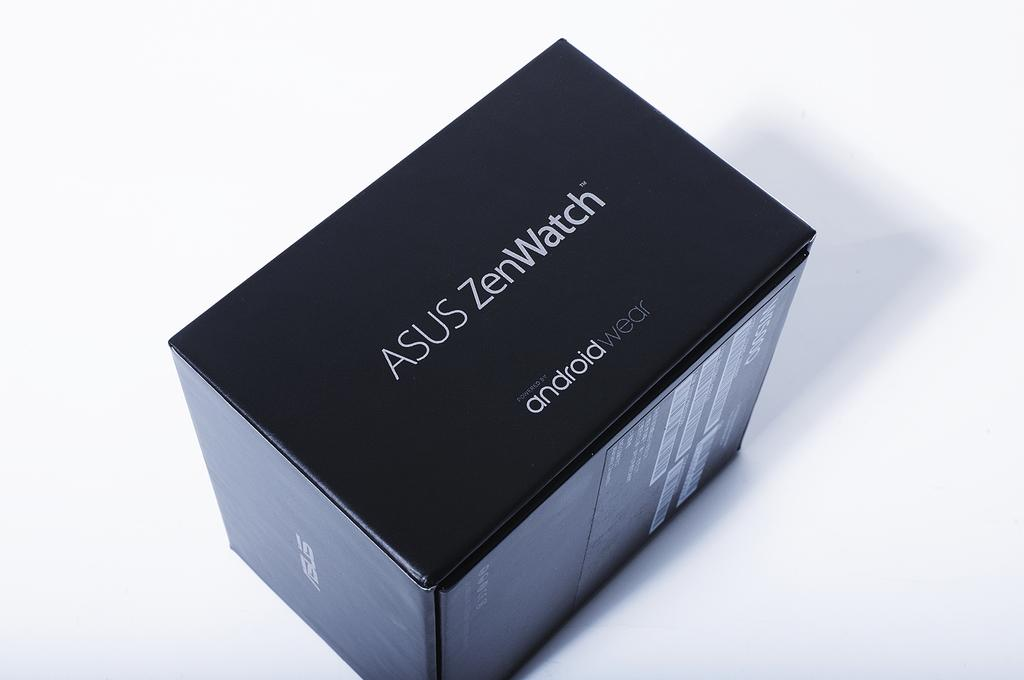What is the color of the watch box in the image? The watch box in the image is black. What type of object is the watch box? The watch box is a container for storing watches. What advice does the grandmother give during the meeting in the image? There is no mention of a grandmother or a meeting in the image; it only features a black color watch box. 